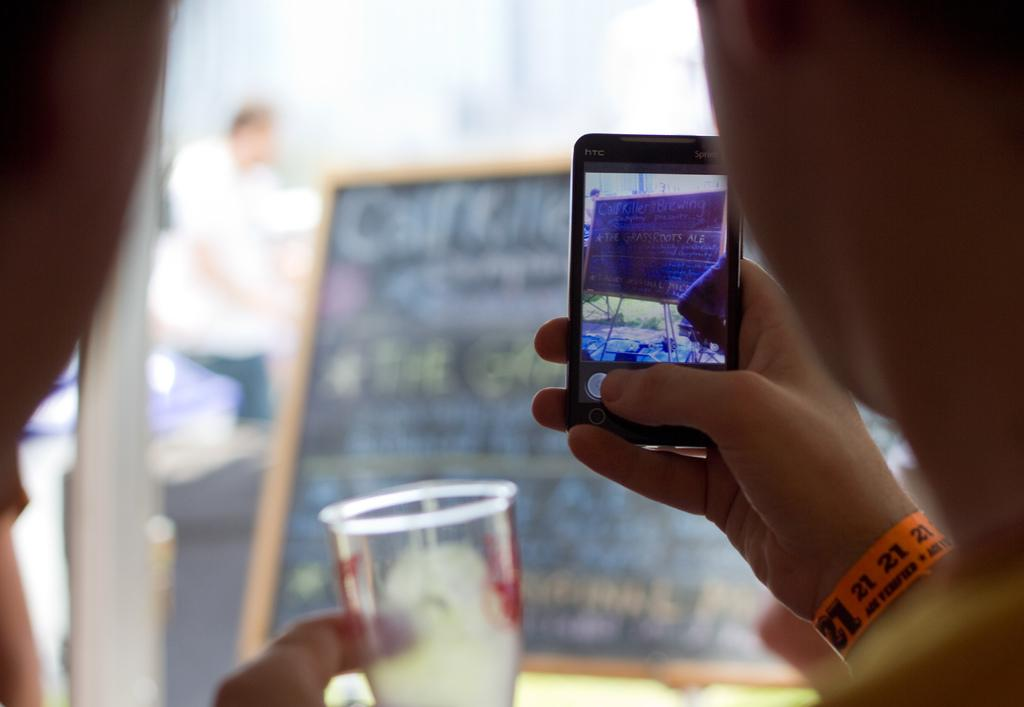<image>
Offer a succinct explanation of the picture presented. an orange band with the numbers 21 on it 